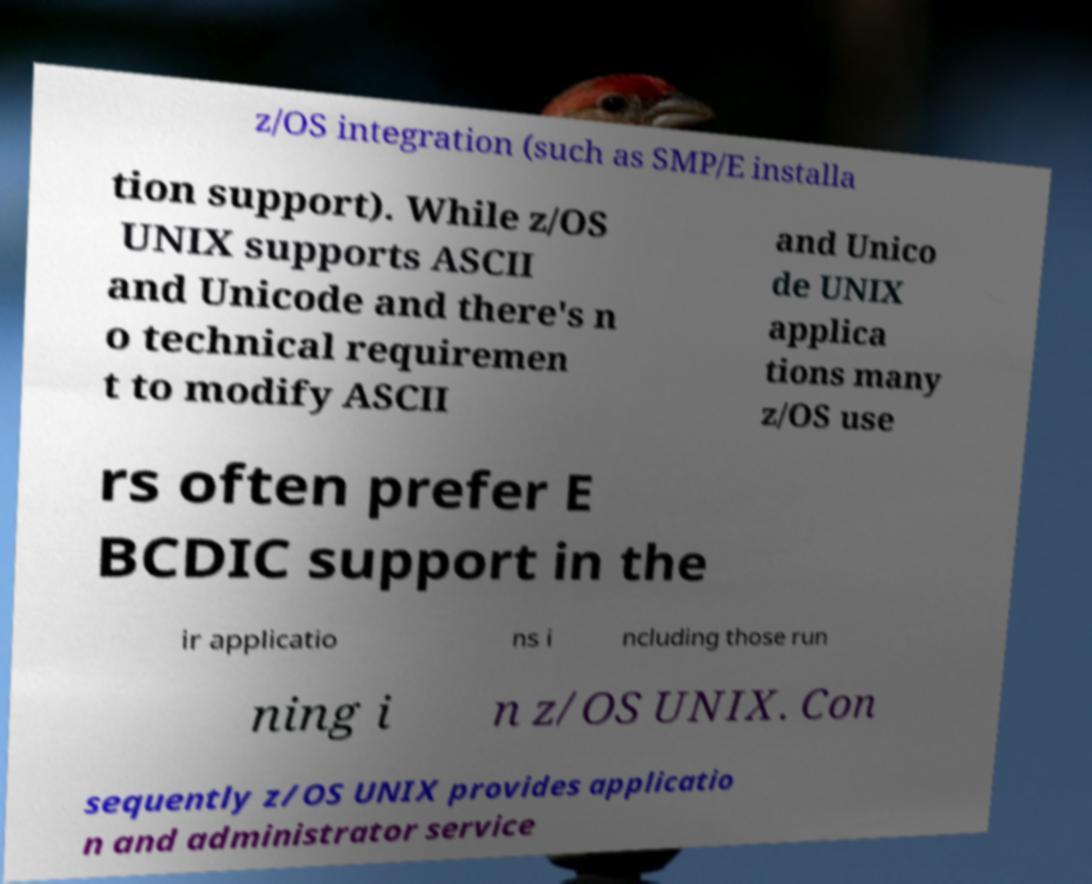What messages or text are displayed in this image? I need them in a readable, typed format. z/OS integration (such as SMP/E installa tion support). While z/OS UNIX supports ASCII and Unicode and there's n o technical requiremen t to modify ASCII and Unico de UNIX applica tions many z/OS use rs often prefer E BCDIC support in the ir applicatio ns i ncluding those run ning i n z/OS UNIX. Con sequently z/OS UNIX provides applicatio n and administrator service 